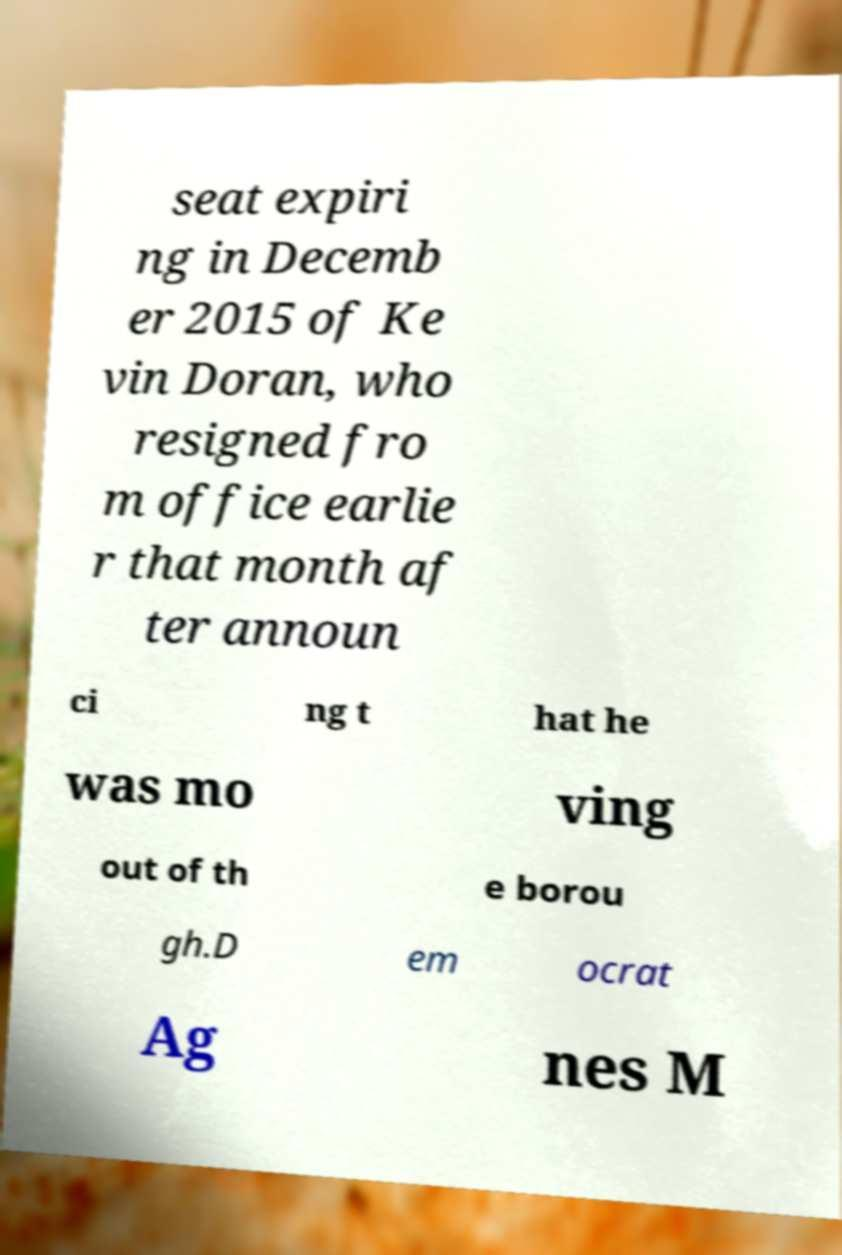What messages or text are displayed in this image? I need them in a readable, typed format. seat expiri ng in Decemb er 2015 of Ke vin Doran, who resigned fro m office earlie r that month af ter announ ci ng t hat he was mo ving out of th e borou gh.D em ocrat Ag nes M 